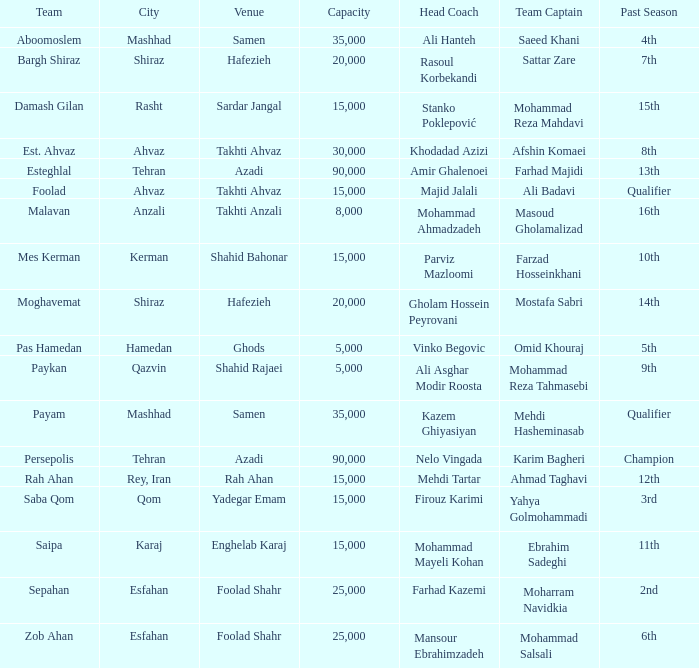What is the Capacity of the Venue of Head Coach Farhad Kazemi? 25000.0. 